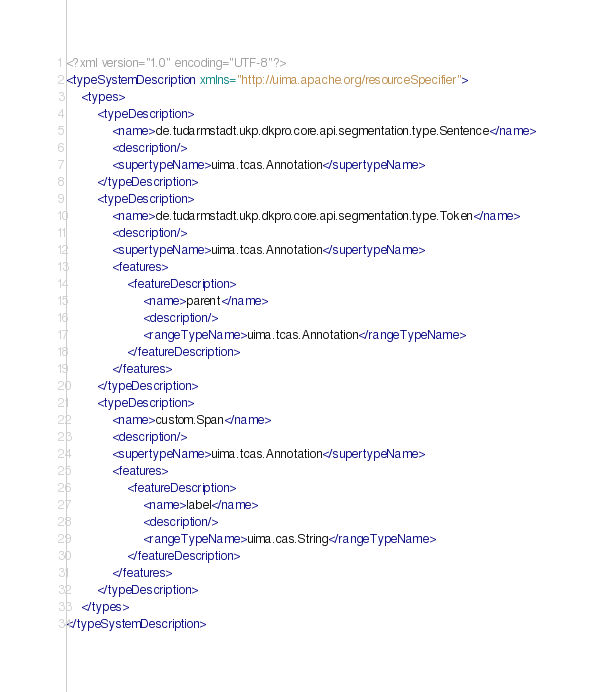<code> <loc_0><loc_0><loc_500><loc_500><_XML_><?xml version="1.0" encoding="UTF-8"?>
<typeSystemDescription xmlns="http://uima.apache.org/resourceSpecifier">
    <types>
        <typeDescription>
            <name>de.tudarmstadt.ukp.dkpro.core.api.segmentation.type.Sentence</name>
            <description/>
            <supertypeName>uima.tcas.Annotation</supertypeName>
        </typeDescription>
        <typeDescription>
            <name>de.tudarmstadt.ukp.dkpro.core.api.segmentation.type.Token</name>
            <description/>
            <supertypeName>uima.tcas.Annotation</supertypeName>
            <features>
                <featureDescription>
                    <name>parent</name>
                    <description/>
                    <rangeTypeName>uima.tcas.Annotation</rangeTypeName>
                </featureDescription>
            </features>
        </typeDescription>
        <typeDescription>
            <name>custom.Span</name>
            <description/>
            <supertypeName>uima.tcas.Annotation</supertypeName>
            <features>
                <featureDescription>
                    <name>label</name>
                    <description/>
                    <rangeTypeName>uima.cas.String</rangeTypeName>
                </featureDescription>
            </features>
        </typeDescription>
    </types>
</typeSystemDescription>
</code> 